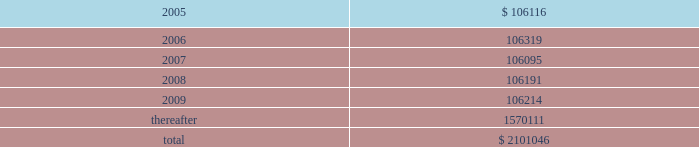American tower corporation and subsidiaries notes to consolidated financial statements 2014 ( continued ) 7 .
Derivative financial instruments under the terms of the credit facility , the company is required to enter into interest rate protection agreements on at least 50% ( 50 % ) of its variable rate debt .
Under these agreements , the company is exposed to credit risk to the extent that a counterparty fails to meet the terms of a contract .
Such exposure is limited to the current value of the contract at the time the counterparty fails to perform .
The company believes its contracts as of december 31 , 2004 are with credit worthy institutions .
As of december 31 , 2004 , the company had two interest rate caps outstanding with an aggregate notional amount of $ 350.0 million ( each at an interest rate of 6.0% ( 6.0 % ) ) that expire in 2006 .
As of december 31 , 2003 , the company had three interest rate caps outstanding with an aggregate notional amount of $ 500.0 million ( each at a rate of 5.0% ( 5.0 % ) ) that expired in 2004 .
As of december 31 , 2004 and 2003 , there was no fair value associated with any of these interest rate caps .
During the year ended december 31 , 2003 , the company recorded an unrealized loss of approximately $ 0.3 million ( net of a tax benefit of approximately $ 0.2 million ) in other comprehensive loss for the change in fair value of cash flow hedges and reclassified $ 5.9 million ( net of a tax benefit of approximately $ 3.2 million ) into results of operations .
During the year ended december 31 , 2002 , the company recorded an unrealized loss of approximately $ 9.1 million ( net of a tax benefit of approximately $ 4.9 million ) in other comprehensive loss for the change in fair value of cash flow hedges and reclassified $ 19.5 million ( net of a tax benefit of approximately $ 10.5 million ) into results of operations .
Hedge ineffectiveness resulted in a gain of approximately $ 1.0 million for the year ended december 31 , 2002 , which is recorded in other expense in the accompanying consolidated statement of operations .
The company records the changes in fair value of its derivative instruments that are not accounted for as hedges in other expense .
The company did not reclassify any derivative losses into its statement of operations for the year ended december 31 , 2004 and does not anticipate reclassifying any derivative losses into its statement of operations within the next twelve months , as there are no amounts included in other comprehensive loss as of december 31 , 2004 .
Commitments and contingencies lease obligations 2014the company leases certain land , office and tower space under operating leases that expire over various terms .
Many of the leases contain renewal options with specified increases in lease payments upon exercise of the renewal option .
Escalation clauses present in operating leases , excluding those tied to cpi or other inflation-based indices , are straight-lined over the term of the lease .
( see note 1. ) future minimum rental payments under non-cancelable operating leases include payments for certain renewal periods at the company 2019s option because failure to renew could result in a loss of the applicable tower site and related revenues from tenant leases , thereby making it reasonably assured that the company will renew the lease .
Such payments in effect at december 31 , 2004 are as follows ( in thousands ) : year ending december 31 .
Aggregate rent expense ( including the effect of straight-line rent expense ) under operating leases for the years ended december 31 , 2004 , 2003 and 2002 approximated $ 118741000 , $ 113956000 , and $ 109644000 , respectively. .
As of december 2004 what was the percent of the total future minimum rental payments under non-cancelable operating leases due in 2009? 
Computations: (106214 / 2101046)
Answer: 0.05055. 